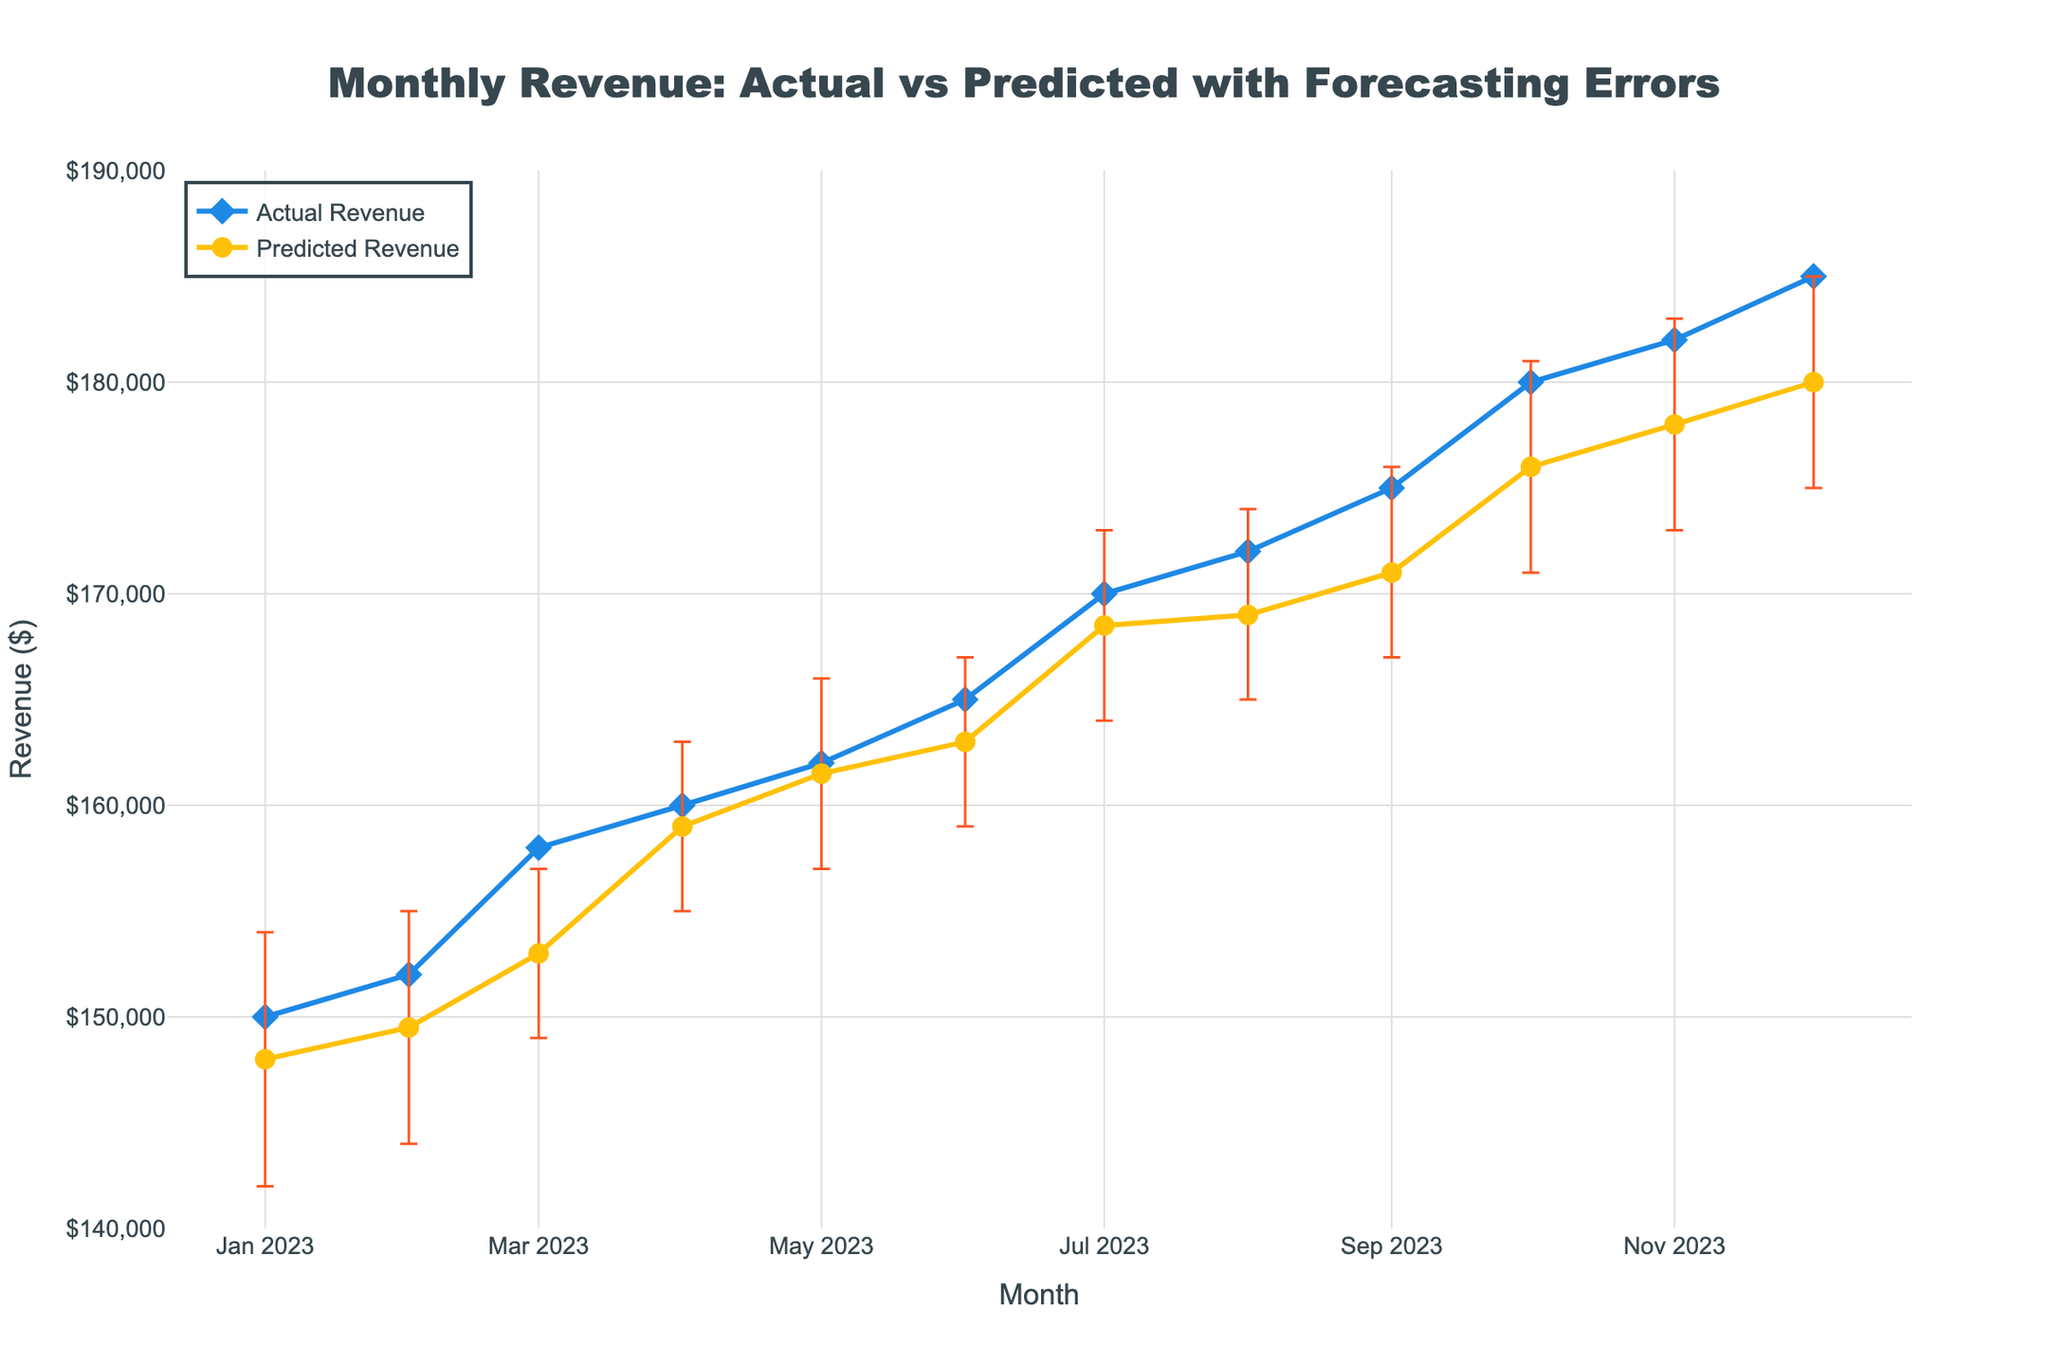What's the title of the figure? The title of a plot is usually displayed at the top of the figure. In this case, the title is "Monthly Revenue: Actual vs Predicted with Forecasting Errors".
Answer: Monthly Revenue: Actual vs Predicted with Forecasting Errors What are the axes titles in the figure? The x-axis title denotes the measure along the horizontal axis, and the y-axis title denotes the measure along the vertical axis. Here, the x-axis title is "Month" and the y-axis title is "Revenue ($)".
Answer: Month; Revenue ($) How many months of data are being displayed? Each data point represents a month, starting from January 2023 to December 2023. Count the number of data points to determine the number of months.
Answer: 12 What is the color of the line representing Actual Revenue? The color of the lines can be identified based on the visual properties. Here, the Actual Revenue line is blue.
Answer: Blue Which month has the highest Actual Revenue? The Actual Revenue can be identified by looking at the highest point on the blue line. The month with the highest value is December 2023 with $185,000.
Answer: December 2023 What is the range of the y-axis? The range of an axis can be determined by looking at the lowest and highest values displayed. For the y-axis, it ranges from $140,000 to $190,000.
Answer: $140,000 to $190,000 During which month did the Predicted Revenue have the largest forecasting error? The largest forecasting error is identified by the widest error bar, which occurs in October 2023, where the range is from $171,000 to $181,000.
Answer: October 2023 What is the difference between the Actual and Predicted Revenue for June 2023? Subtract the Predicted Revenue from the Actual Revenue for June. The values are $165,000 and $163,000, respectively, so the difference is $2,000.
Answer: $2,000 What's the average Predicted Revenue for the first quarter of 2023? The first quarter includes January, February, and March. The Predicted Revenues are $148,000, $149,500, and $153,000. Average these values: ($148,000 + $149,500 + $153,000) / 3 = $150,833.33.
Answer: $150,833.33 In which month does the Predicted Revenue most closely match the Actual Revenue? This is found by comparing the Actual and Predicted Revenues and identifying the smallest difference, which occurs in April 2023 with $160,000 (Actual) and $159,000 (Predicted).
Answer: April 2023 